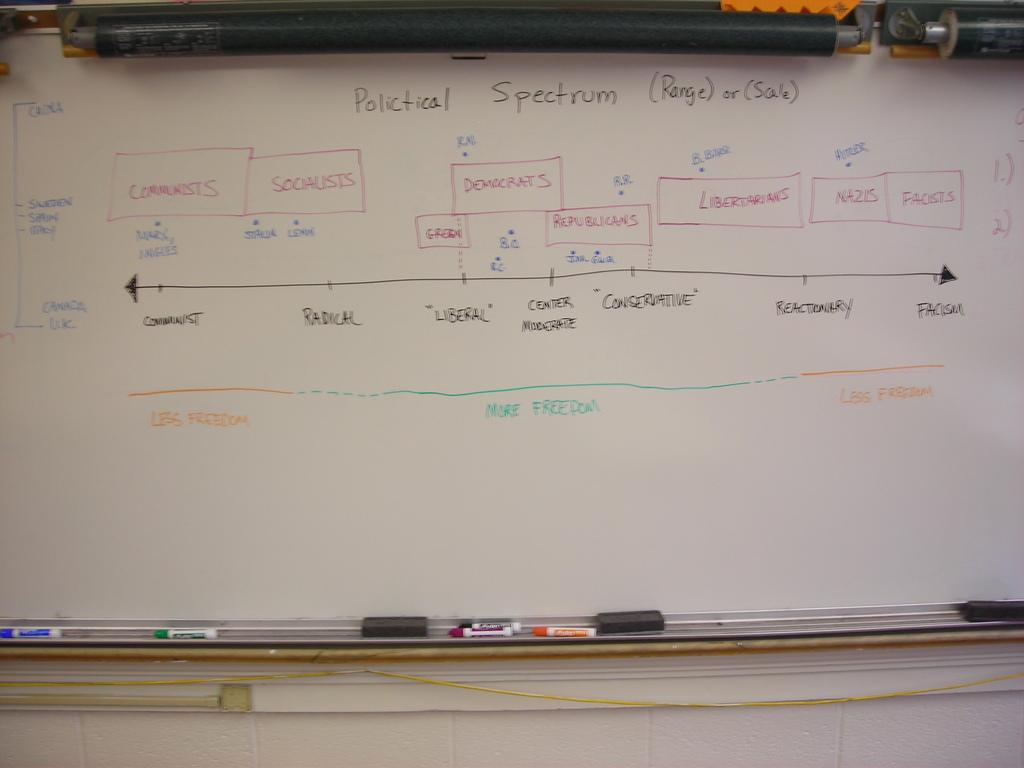<image>
Give a short and clear explanation of the subsequent image. A chart showing differences the Political Spectrum between facism and communism. 